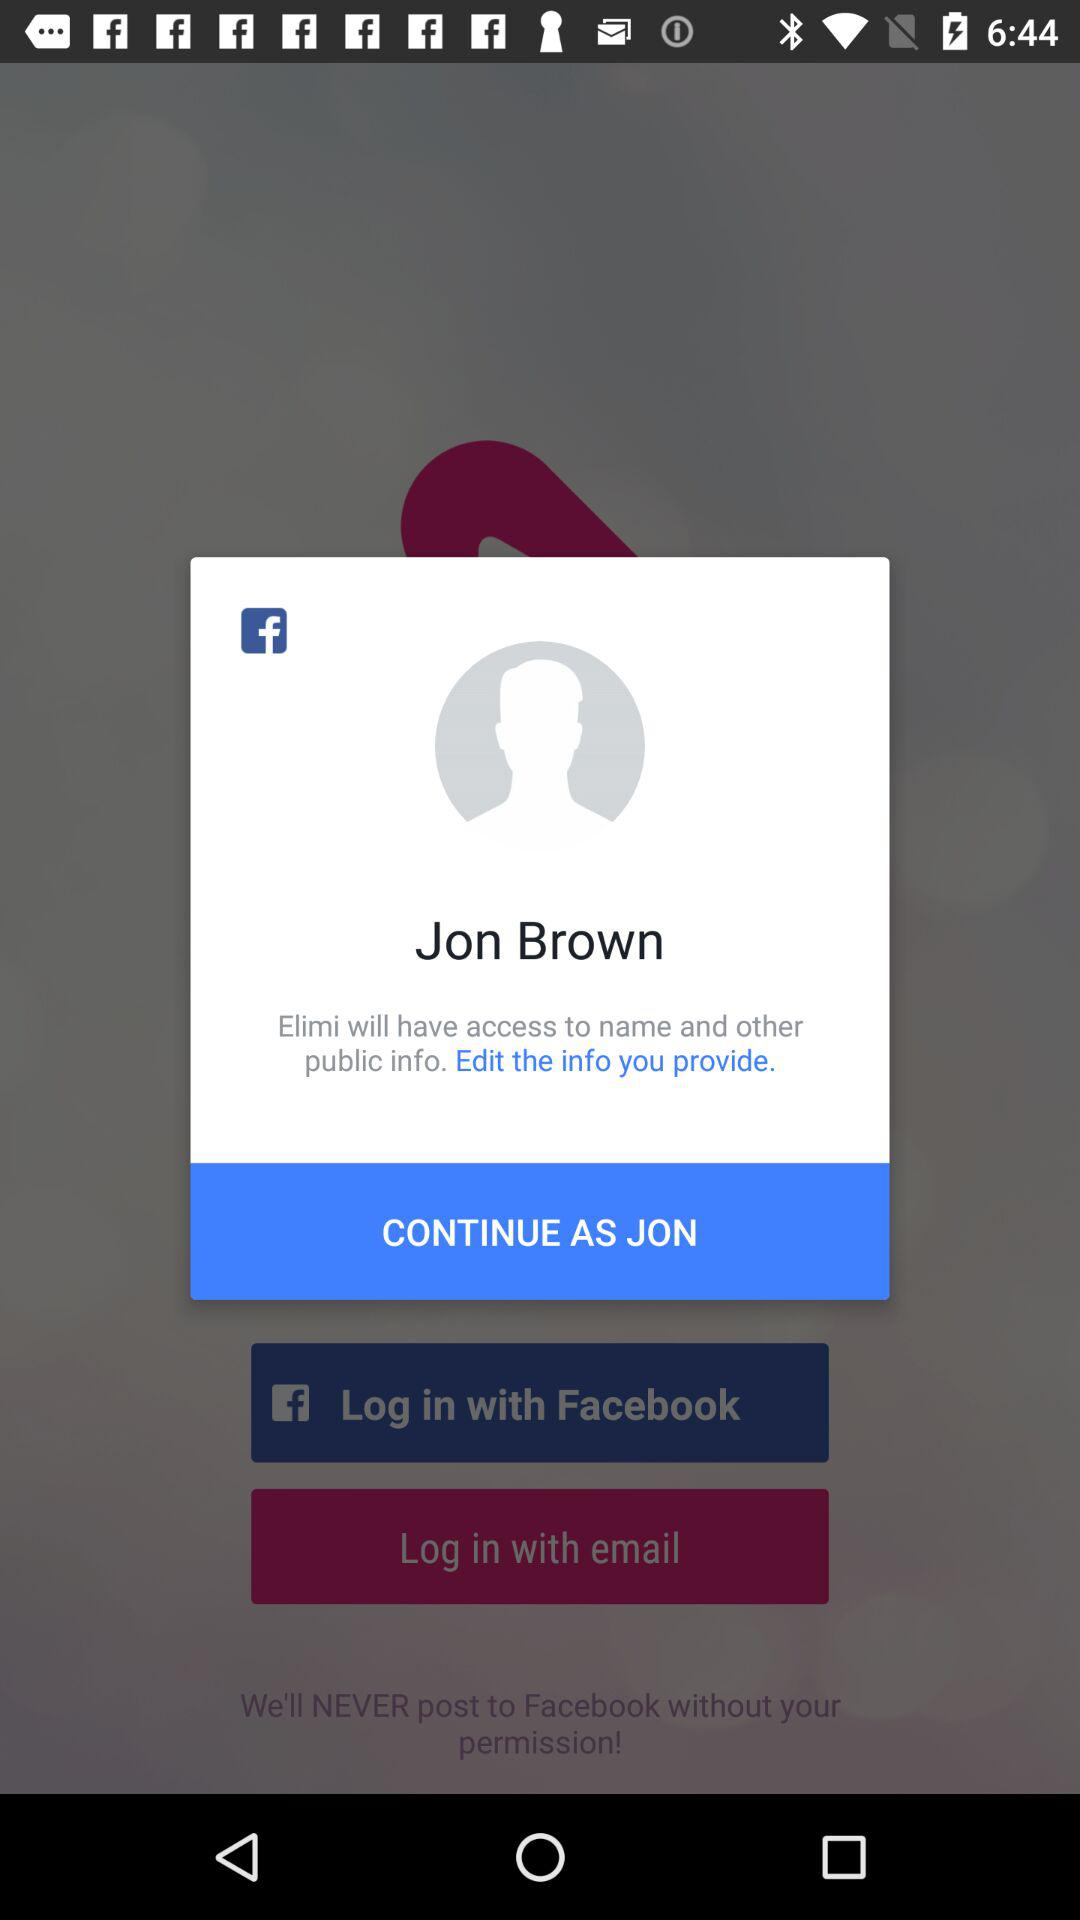What name can we use to log in to "Facebook"? The name that you can use to log in to "Facebook" is Jon Brown. 